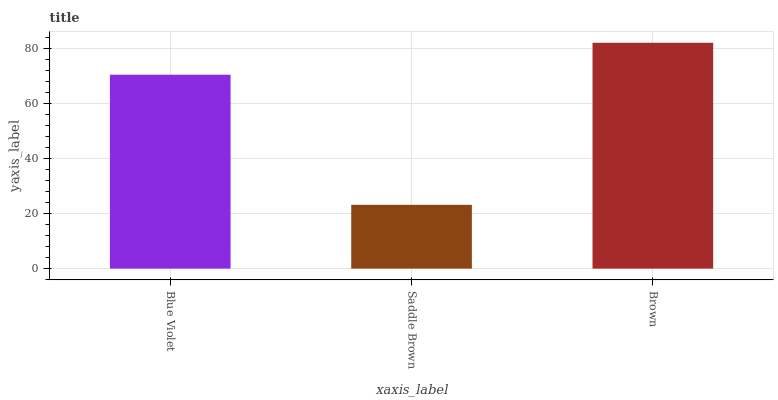Is Saddle Brown the minimum?
Answer yes or no. Yes. Is Brown the maximum?
Answer yes or no. Yes. Is Brown the minimum?
Answer yes or no. No. Is Saddle Brown the maximum?
Answer yes or no. No. Is Brown greater than Saddle Brown?
Answer yes or no. Yes. Is Saddle Brown less than Brown?
Answer yes or no. Yes. Is Saddle Brown greater than Brown?
Answer yes or no. No. Is Brown less than Saddle Brown?
Answer yes or no. No. Is Blue Violet the high median?
Answer yes or no. Yes. Is Blue Violet the low median?
Answer yes or no. Yes. Is Saddle Brown the high median?
Answer yes or no. No. Is Brown the low median?
Answer yes or no. No. 